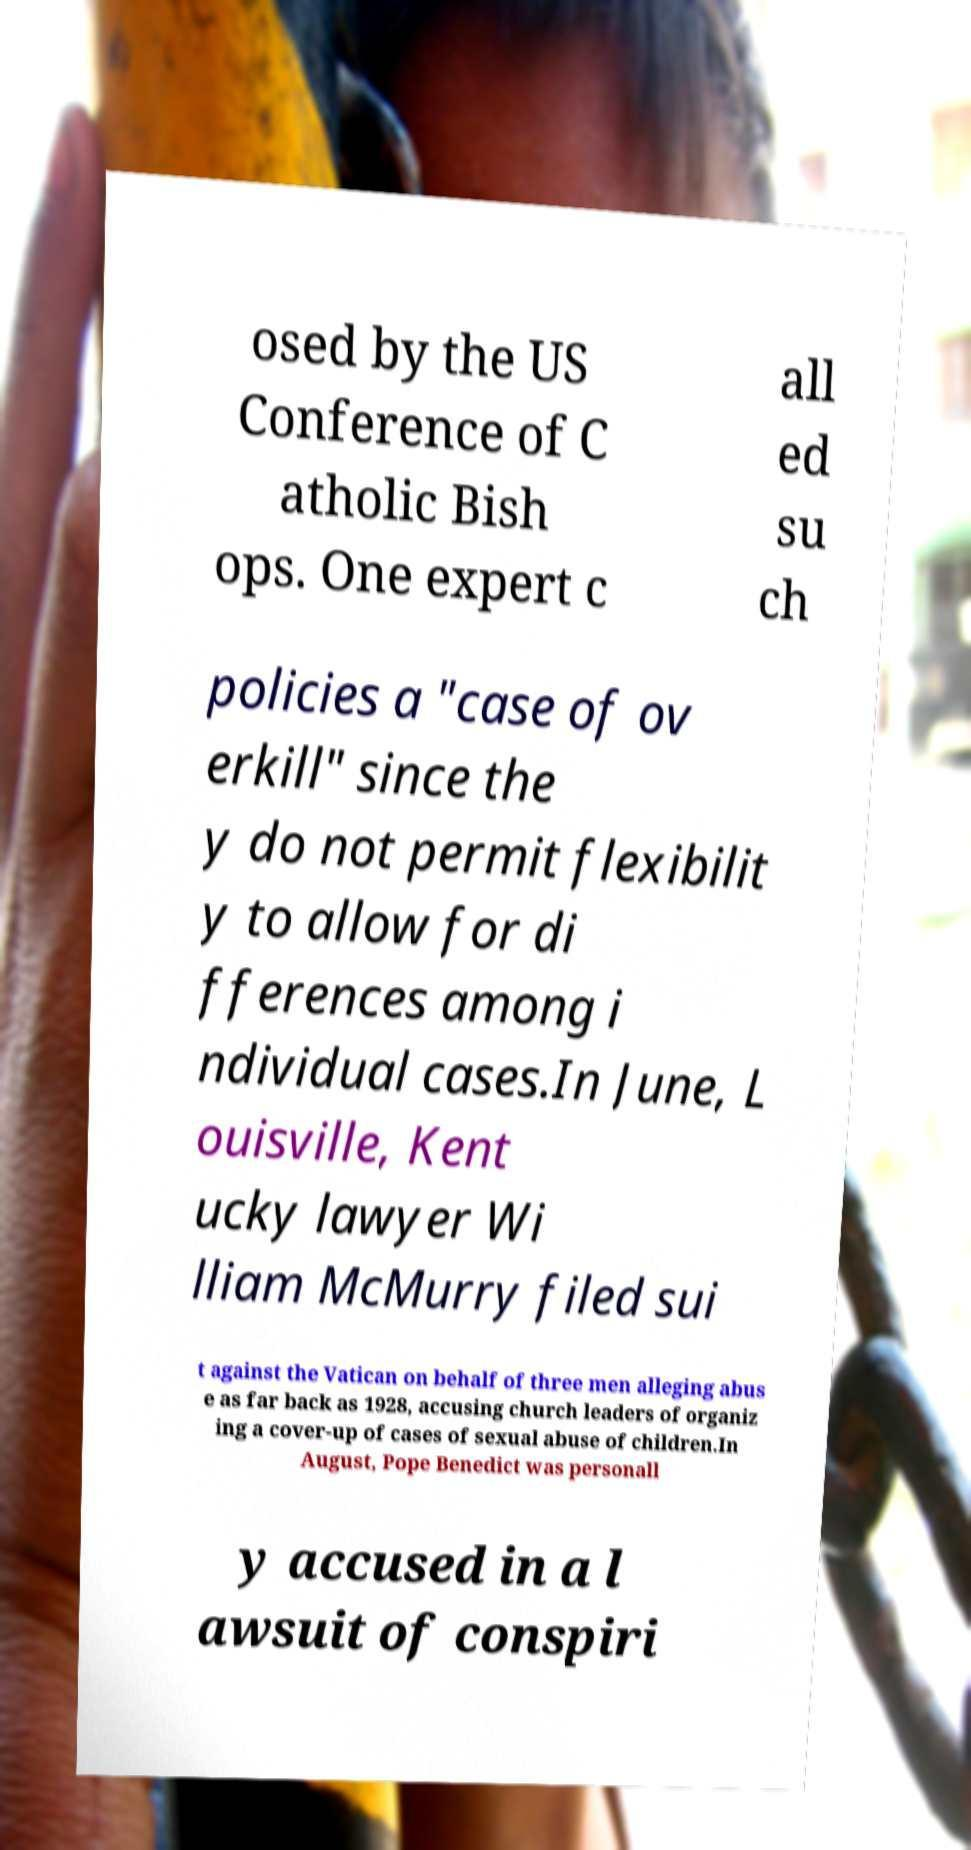Can you read and provide the text displayed in the image?This photo seems to have some interesting text. Can you extract and type it out for me? osed by the US Conference of C atholic Bish ops. One expert c all ed su ch policies a "case of ov erkill" since the y do not permit flexibilit y to allow for di fferences among i ndividual cases.In June, L ouisville, Kent ucky lawyer Wi lliam McMurry filed sui t against the Vatican on behalf of three men alleging abus e as far back as 1928, accusing church leaders of organiz ing a cover-up of cases of sexual abuse of children.In August, Pope Benedict was personall y accused in a l awsuit of conspiri 